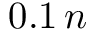Convert formula to latex. <formula><loc_0><loc_0><loc_500><loc_500>0 . 1 \, n</formula> 